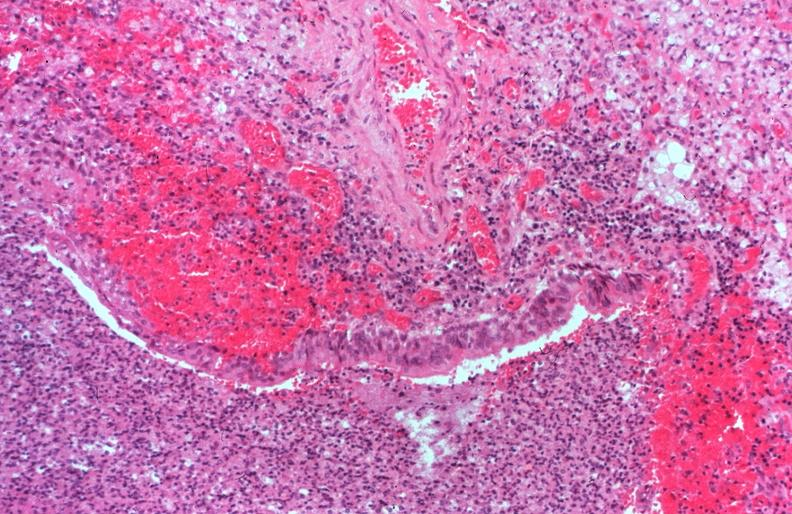does this image show lung, cystic fibrosis?
Answer the question using a single word or phrase. Yes 